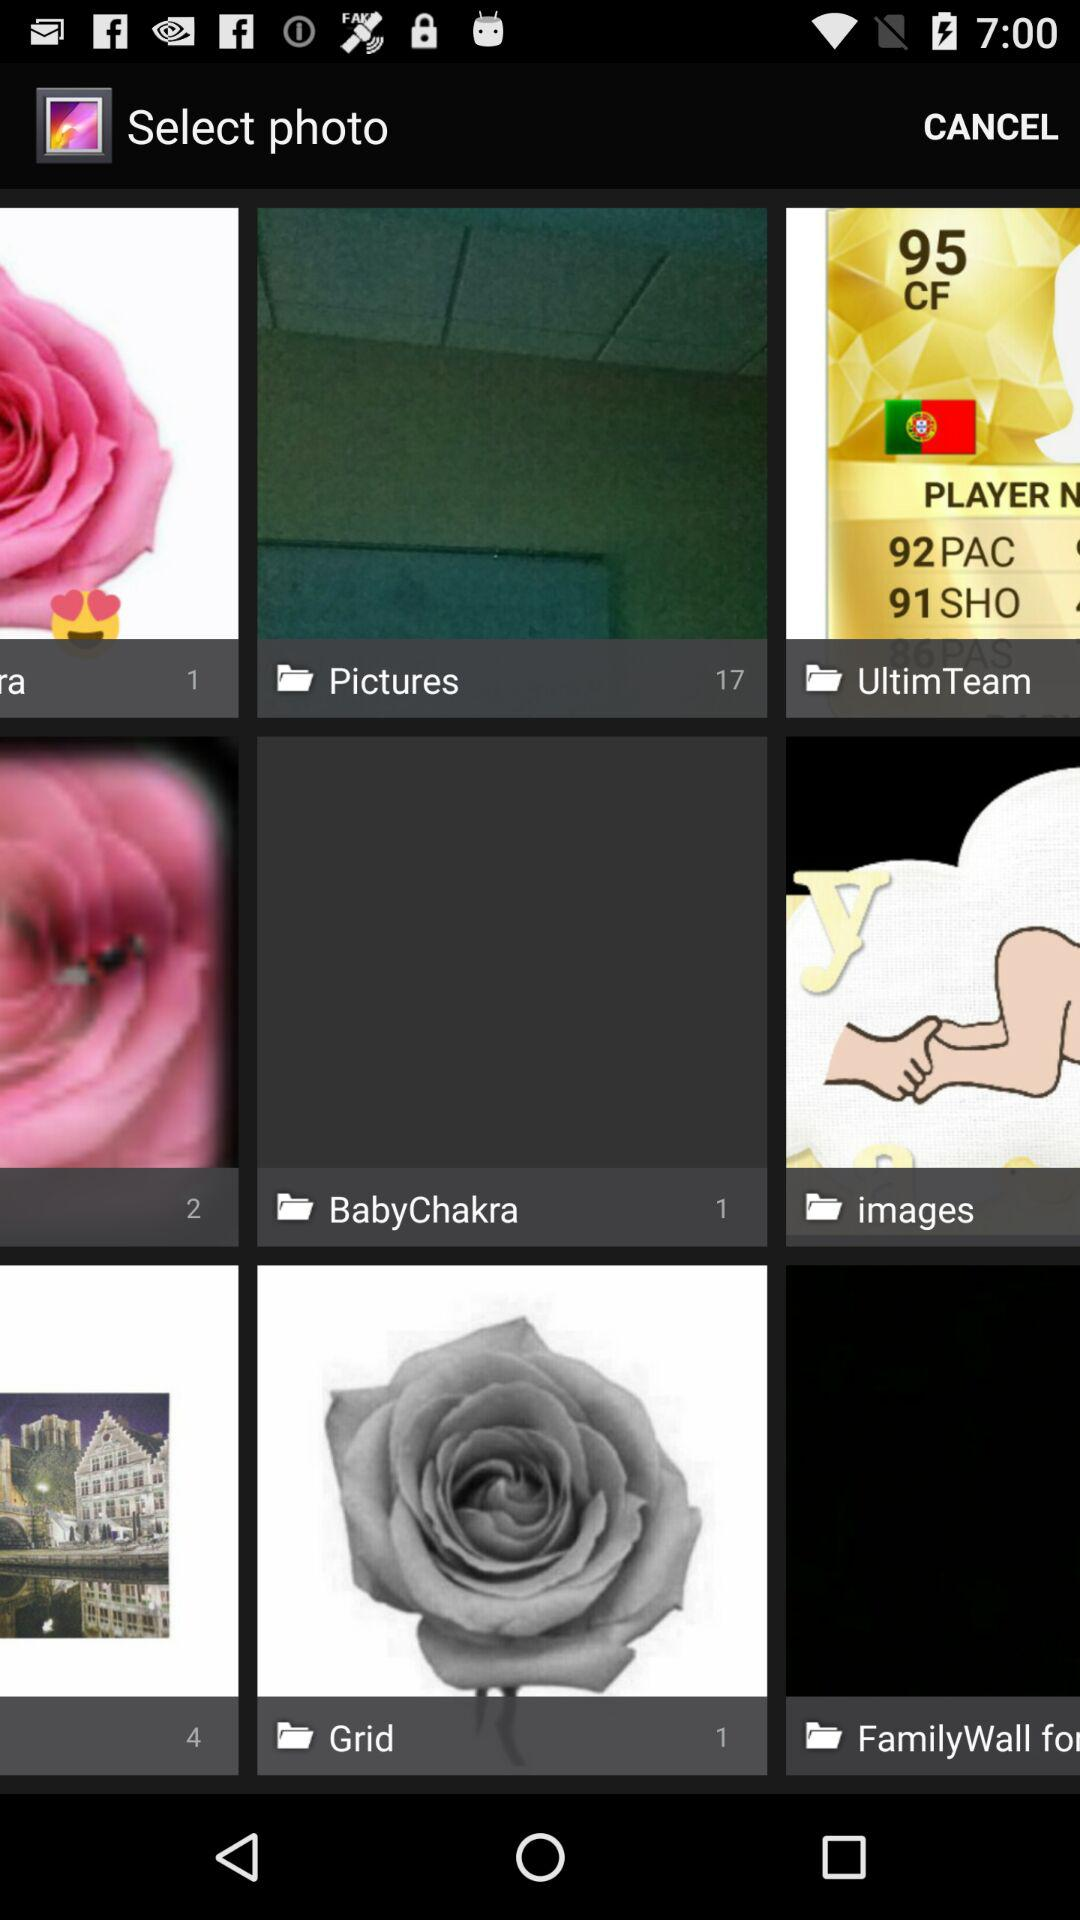What is the number of images in "BabyChakra"? The number of images is 1. 